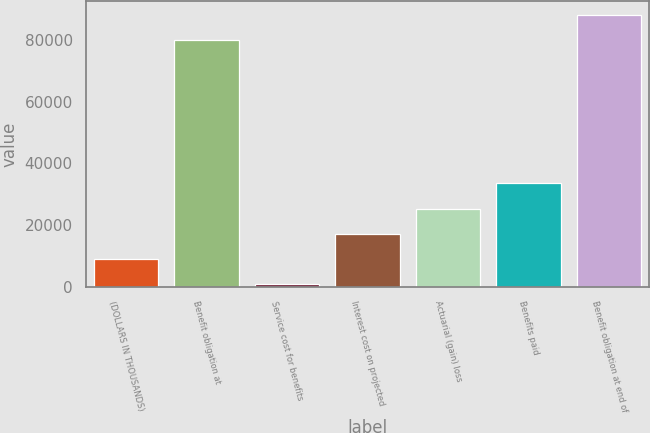<chart> <loc_0><loc_0><loc_500><loc_500><bar_chart><fcel>(DOLLARS IN THOUSANDS)<fcel>Benefit obligation at<fcel>Service cost for benefits<fcel>Interest cost on projected<fcel>Actuarial (gain) loss<fcel>Benefits paid<fcel>Benefit obligation at end of<nl><fcel>8917.6<fcel>79845<fcel>718<fcel>17117.2<fcel>25316.8<fcel>33516.4<fcel>88044.6<nl></chart> 